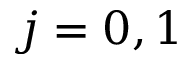<formula> <loc_0><loc_0><loc_500><loc_500>j = 0 , 1</formula> 